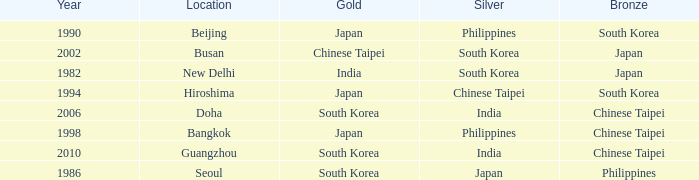Which Year is the highest one that has a Bronze of south korea, and a Silver of philippines? 1990.0. 